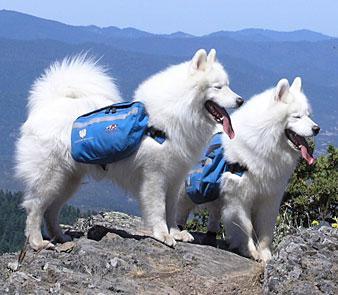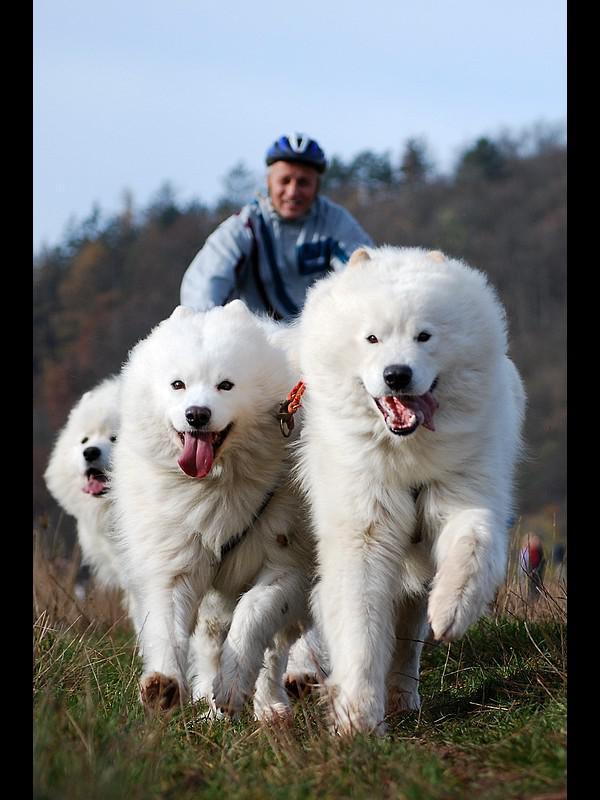The first image is the image on the left, the second image is the image on the right. Analyze the images presented: Is the assertion "A person is visible behind three white dogs in one image." valid? Answer yes or no. Yes. The first image is the image on the left, the second image is the image on the right. Analyze the images presented: Is the assertion "In one image, three white dogs are with a person." valid? Answer yes or no. Yes. 